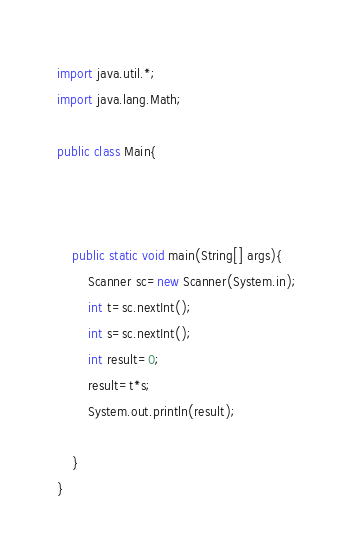<code> <loc_0><loc_0><loc_500><loc_500><_Java_>import java.util.*;
import java.lang.Math;

public class Main{
    
    
        
    public static void main(String[] args){
        Scanner sc=new Scanner(System.in);
        int t=sc.nextInt();
        int s=sc.nextInt();
        int result=0;
        result=t*s;
        System.out.println(result);
        
    }
}</code> 